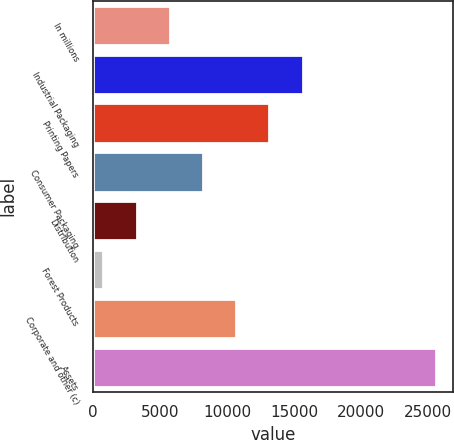<chart> <loc_0><loc_0><loc_500><loc_500><bar_chart><fcel>In millions<fcel>Industrial Packaging<fcel>Printing Papers<fcel>Consumer Packaging<fcel>Distribution<fcel>Forest Products<fcel>Corporate and other (c)<fcel>Assets<nl><fcel>5716<fcel>15632<fcel>13153<fcel>8195<fcel>3237<fcel>758<fcel>10674<fcel>25548<nl></chart> 